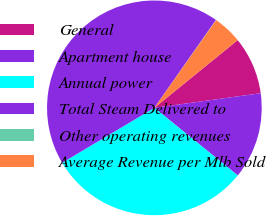Convert chart to OTSL. <chart><loc_0><loc_0><loc_500><loc_500><pie_chart><fcel>General<fcel>Apartment house<fcel>Annual power<fcel>Total Steam Delivered to<fcel>Other operating revenues<fcel>Average Revenue per Mlb Sold<nl><fcel>8.69%<fcel>13.02%<fcel>30.6%<fcel>43.29%<fcel>0.04%<fcel>4.37%<nl></chart> 